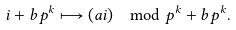Convert formula to latex. <formula><loc_0><loc_0><loc_500><loc_500>i + b p ^ { k } & \longmapsto ( a i ) \mod p ^ { k } + b p ^ { k } .</formula> 